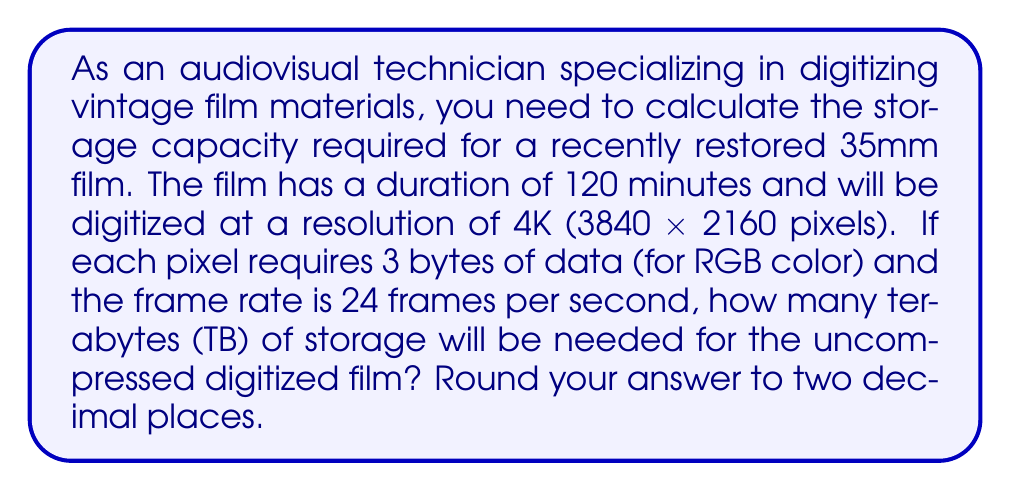Show me your answer to this math problem. To solve this problem, we need to follow these steps:

1. Calculate the number of pixels per frame:
   $$ \text{Pixels per frame} = 3840 \times 2160 = 8,294,400 \text{ pixels} $$

2. Calculate the number of bytes per frame:
   $$ \text{Bytes per frame} = 8,294,400 \times 3 = 24,883,200 \text{ bytes} $$

3. Calculate the number of frames in the entire film:
   $$ \text{Total frames} = 120 \text{ minutes} \times 60 \text{ seconds/minute} \times 24 \text{ frames/second} = 172,800 \text{ frames} $$

4. Calculate the total number of bytes for the entire film:
   $$ \text{Total bytes} = 24,883,200 \times 172,800 = 4,299,816,960,000 \text{ bytes} $$

5. Convert bytes to terabytes (1 TB = 1,099,511,627,776 bytes):
   $$ \text{Terabytes} = \frac{4,299,816,960,000}{1,099,511,627,776} \approx 3.91 \text{ TB} $$
Answer: 3.91 TB 